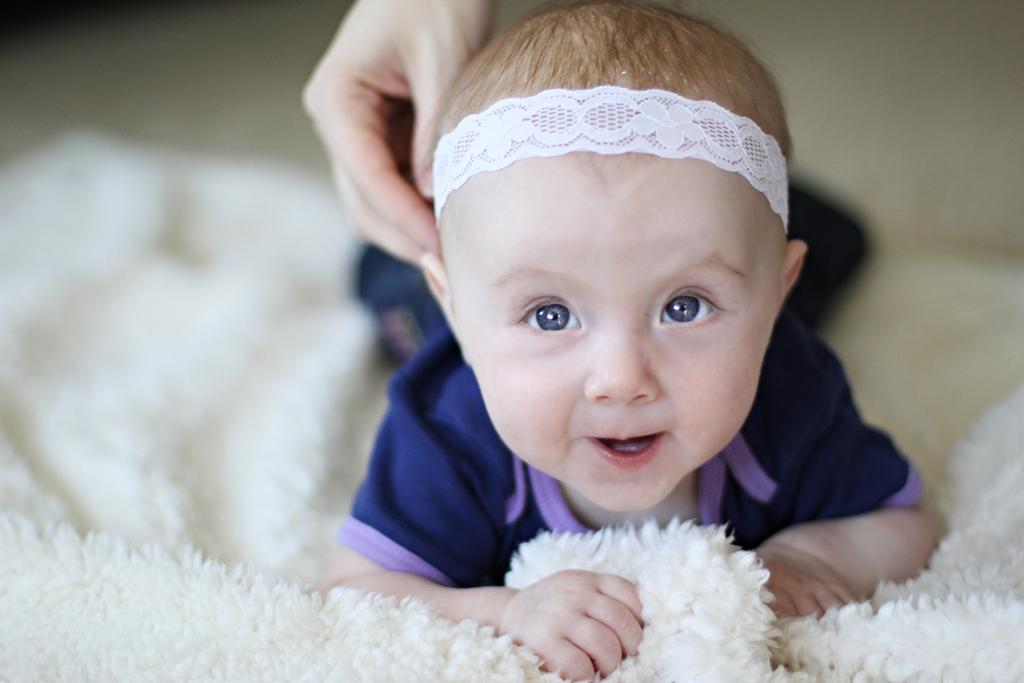What is the main subject of the image? There is a baby lying on cloth in the image. Can you describe any other elements in the image? A person's hand is visible in the image. How would you describe the background of the image? The background of the image is blurry. What type of ticket is the baby holding in the image? There is no ticket present in the image; the baby is lying on cloth. How does the baby's hair look in the image? The image does not show the baby's hair, as the baby is lying on cloth and only a small part of the baby's body is visible. 